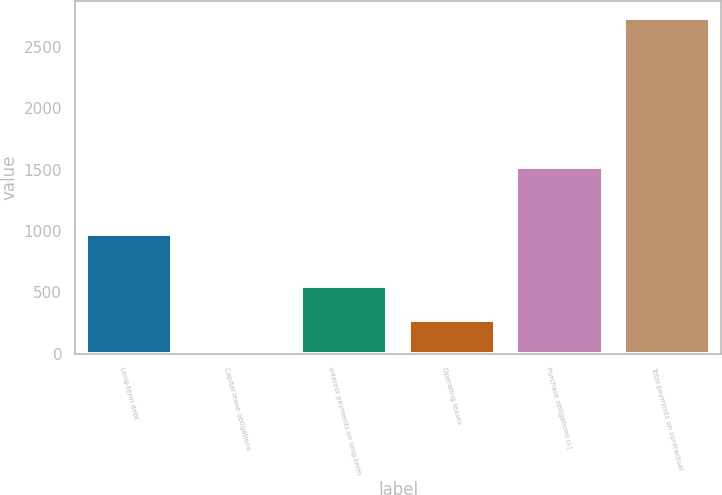Convert chart to OTSL. <chart><loc_0><loc_0><loc_500><loc_500><bar_chart><fcel>Long-term debt<fcel>Capital lease obligations<fcel>Interest payments on long-term<fcel>Operating leases<fcel>Purchase obligations (c)<fcel>Total payments on contractual<nl><fcel>972.9<fcel>0.4<fcel>548.6<fcel>274.5<fcel>1524.6<fcel>2741.4<nl></chart> 